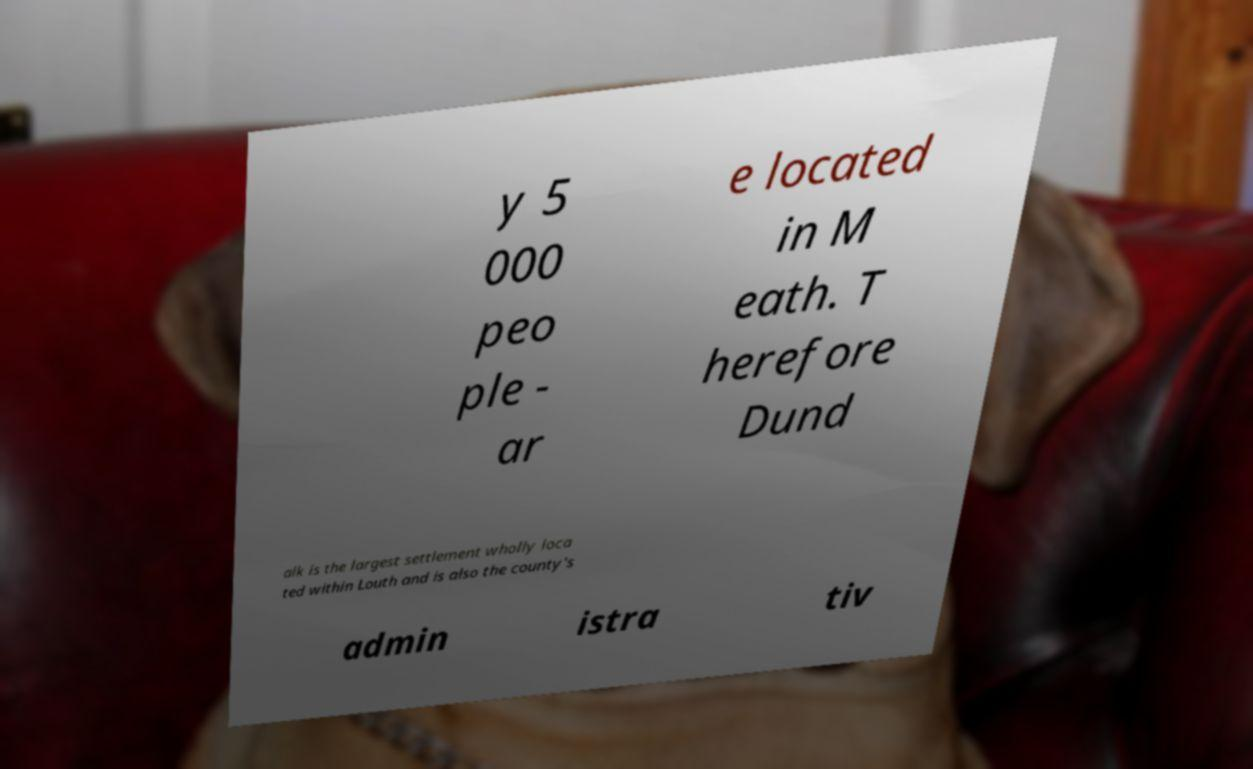Can you read and provide the text displayed in the image?This photo seems to have some interesting text. Can you extract and type it out for me? y 5 000 peo ple - ar e located in M eath. T herefore Dund alk is the largest settlement wholly loca ted within Louth and is also the county's admin istra tiv 